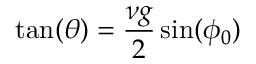<formula> <loc_0><loc_0><loc_500><loc_500>\tan ( \theta ) = \frac { \nu g } { 2 } \sin ( \phi _ { 0 } )</formula> 